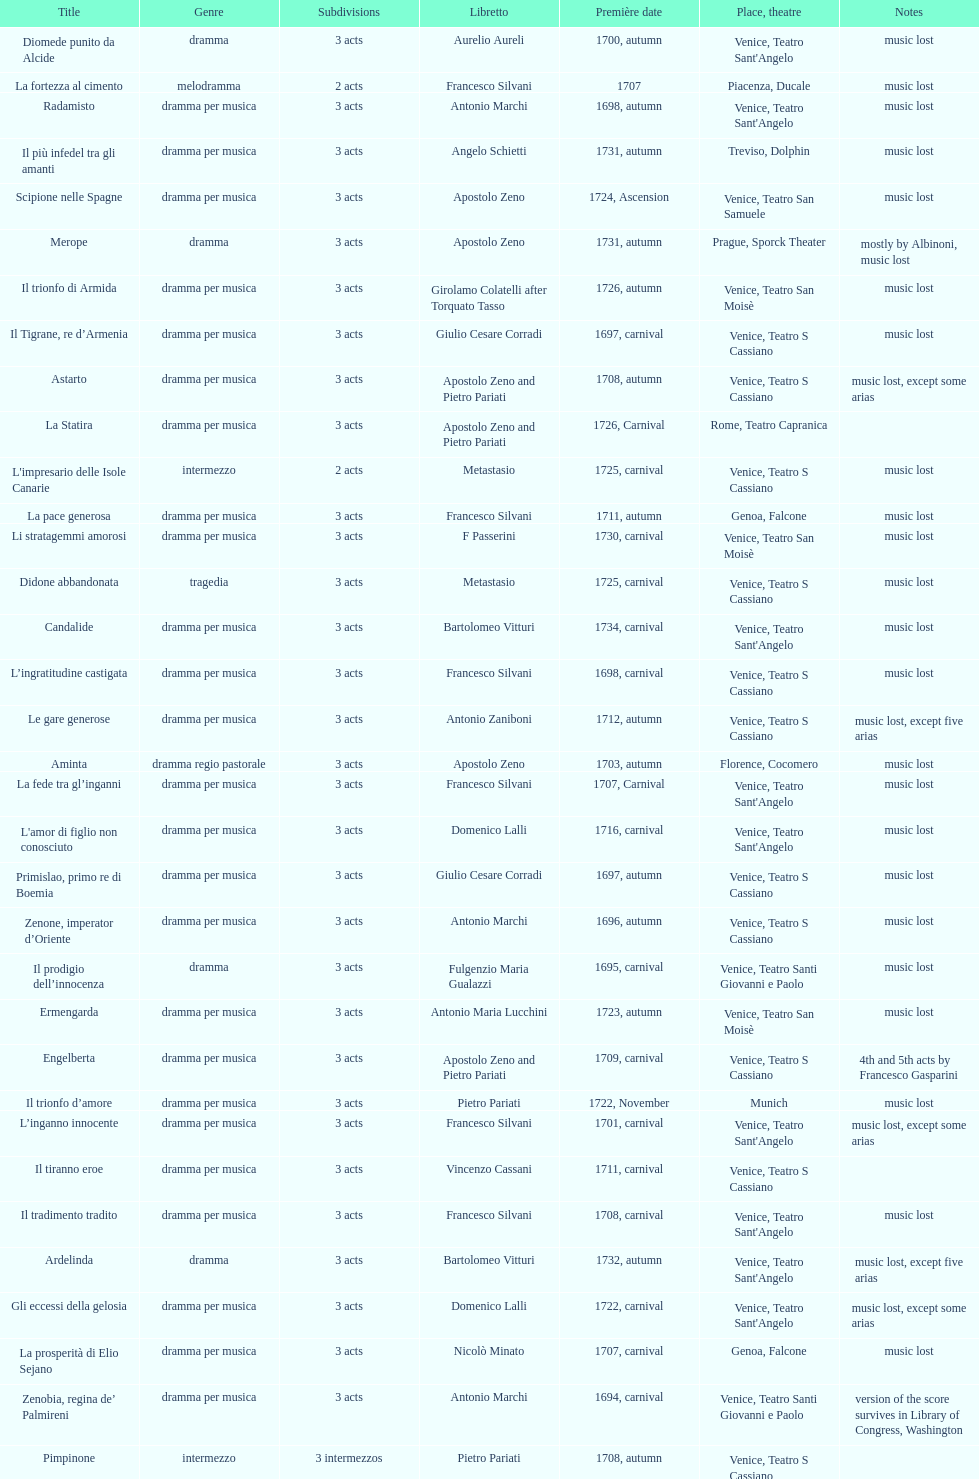How many operas on this list has at least 3 acts? 51. 